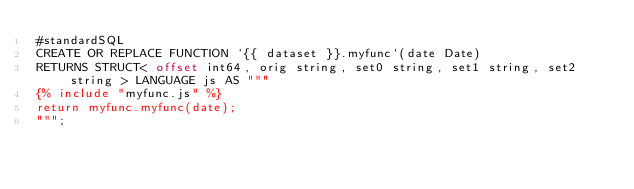<code> <loc_0><loc_0><loc_500><loc_500><_SQL_>#standardSQL
CREATE OR REPLACE FUNCTION `{{ dataset }}.myfunc`(date Date)
RETURNS STRUCT< offset int64, orig string, set0 string, set1 string, set2 string > LANGUAGE js AS """
{% include "myfunc.js" %}
return myfunc.myfunc(date);
""";
</code> 